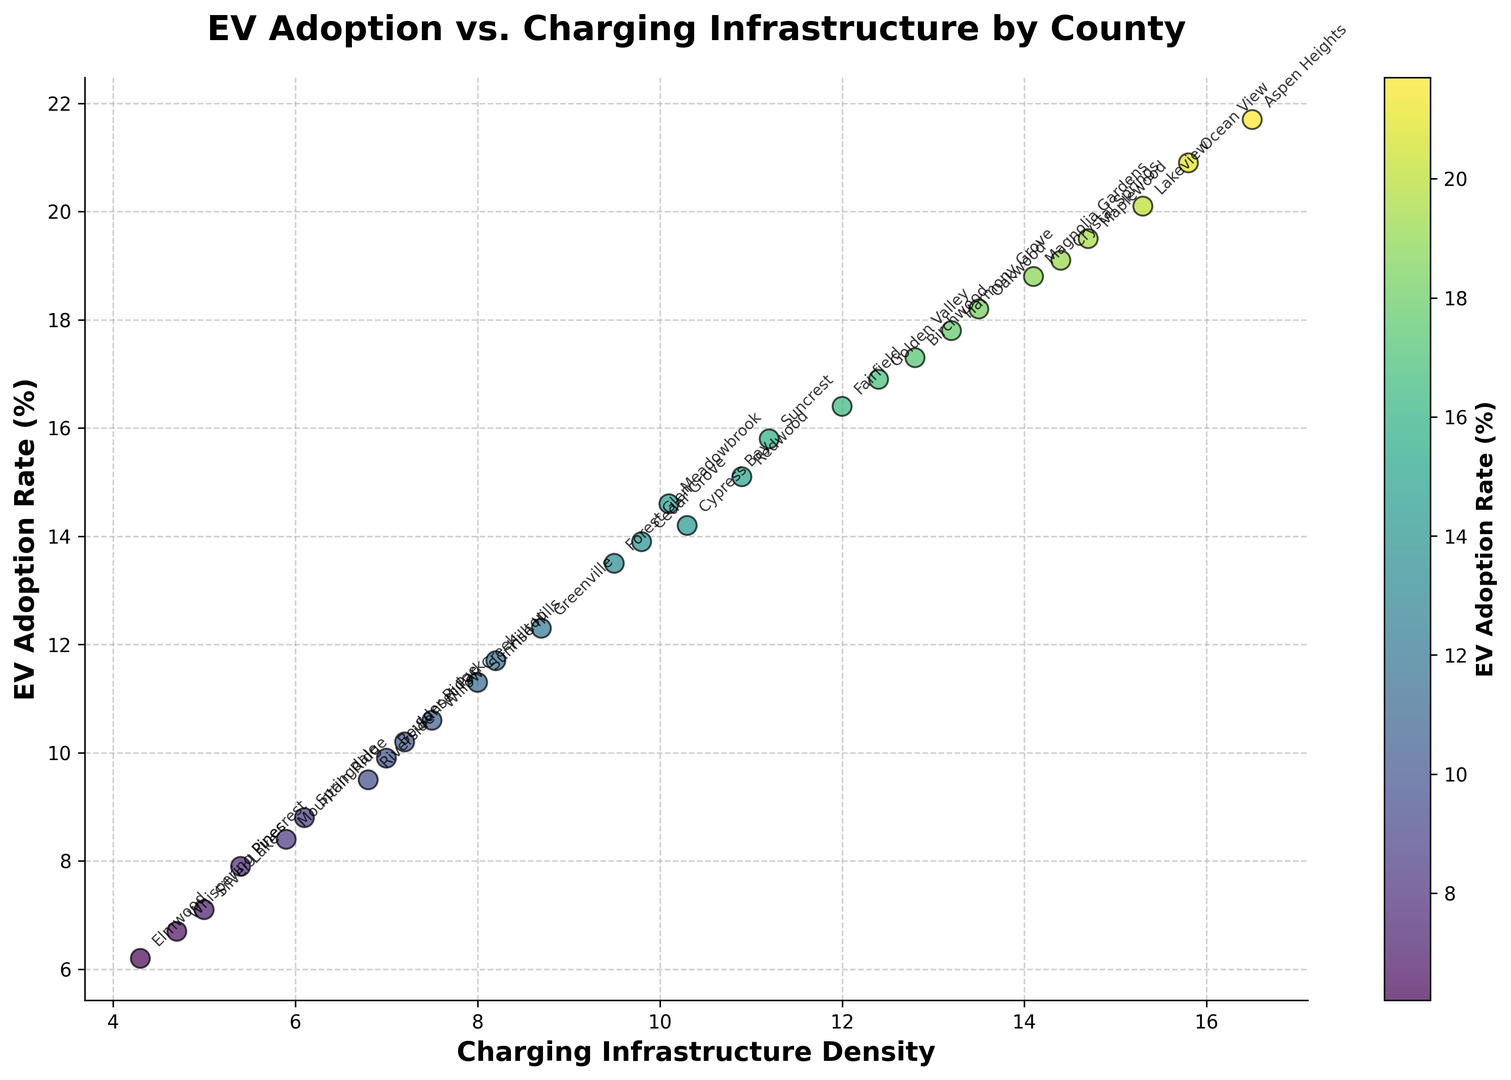What's the relationship between EV adoption rate and charging infrastructure density for the counties with the highest and lowest EV adoption rates? We need to identify the counties with the highest and lowest EV adoption rates and then look at their charging infrastructure densities. Aspen Heights has the highest EV adoption rate at 21.7% and a charging infrastructure density of 16.5. Elmwood has the lowest EV adoption rate at 6.2% and a charging infrastructure density of 4.3.
Answer: Aspen Heights: 16.5, Elmwood: 4.3 Which county has the highest charging infrastructure density, and what is its EV adoption rate? By visually inspecting the x-axis for the highest value, Ocean View has the highest charging infrastructure density of 15.8. The corresponding y-value for its EV adoption rate is 20.9%.
Answer: Ocean View: 20.9% Is there a noticeable trend between EV adoption rate and charging infrastructure density? To deduce this, we observe that counties with higher charging infrastructure density generally have higher EV adoption rates, indicating a positive correlation. Most points on the scatter plot follow this upward trend.
Answer: Yes, a positive correlation Which county has the closest EV adoption rate to the median value, and what is its charging infrastructure density? First, we arrange the EV adoption rates in ascending order and find the median. The median value falls between 14.2% and 14.6%. Meadowbrook, with an EV adoption rate of 14.6%, is the closest to the median rate. Its charging infrastructure density is 10.1.
Answer: Meadowbrook: 10.1 What is the average EV adoption rate for all counties? To determine the average, sum all EV adoption rates and divide by the number of counties. Sum = 341.5, Number of counties = 20, Average = 341.5 / 20 = 16.07
Answer: 16.07 How many counties have an EV adoption rate greater than 16% and what are their names? By examining the data points, the counties above this threshold are: Suncrest, Oakwood, Lakeview, Fairfield, Birchwood, Golden Valley, Aspen Heights, Ocean View, Crystal Springs, Harmony Grove, and Magnolia Gardens. The total count is 11 counties.
Answer: 11 counties: Suncrest, Oakwood, Lakeview, Fairfield, Birchwood, Golden Valley, Aspen Heights, Ocean View, Crystal Springs, Harmony Grove, Magnolia Gardens Which county has the highest EV adoption rate relative to its charging infrastructure density, and what is the specific ratio? To find the highest ratio, we divide each EV adoption rate by its respective charging infrastructure density and compare. Aspen Heights has the highest EV adoption rate of 21.7 with a density of 16.5, giving a ratio of approximately 1.32.
Answer: Aspen Heights: ~1.32 